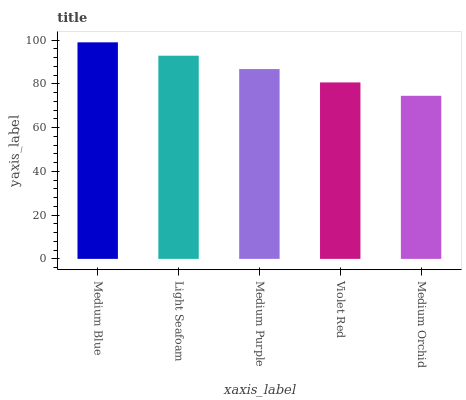Is Medium Orchid the minimum?
Answer yes or no. Yes. Is Medium Blue the maximum?
Answer yes or no. Yes. Is Light Seafoam the minimum?
Answer yes or no. No. Is Light Seafoam the maximum?
Answer yes or no. No. Is Medium Blue greater than Light Seafoam?
Answer yes or no. Yes. Is Light Seafoam less than Medium Blue?
Answer yes or no. Yes. Is Light Seafoam greater than Medium Blue?
Answer yes or no. No. Is Medium Blue less than Light Seafoam?
Answer yes or no. No. Is Medium Purple the high median?
Answer yes or no. Yes. Is Medium Purple the low median?
Answer yes or no. Yes. Is Light Seafoam the high median?
Answer yes or no. No. Is Medium Orchid the low median?
Answer yes or no. No. 